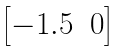<formula> <loc_0><loc_0><loc_500><loc_500>\begin{bmatrix} - 1 . 5 & 0 \end{bmatrix}</formula> 